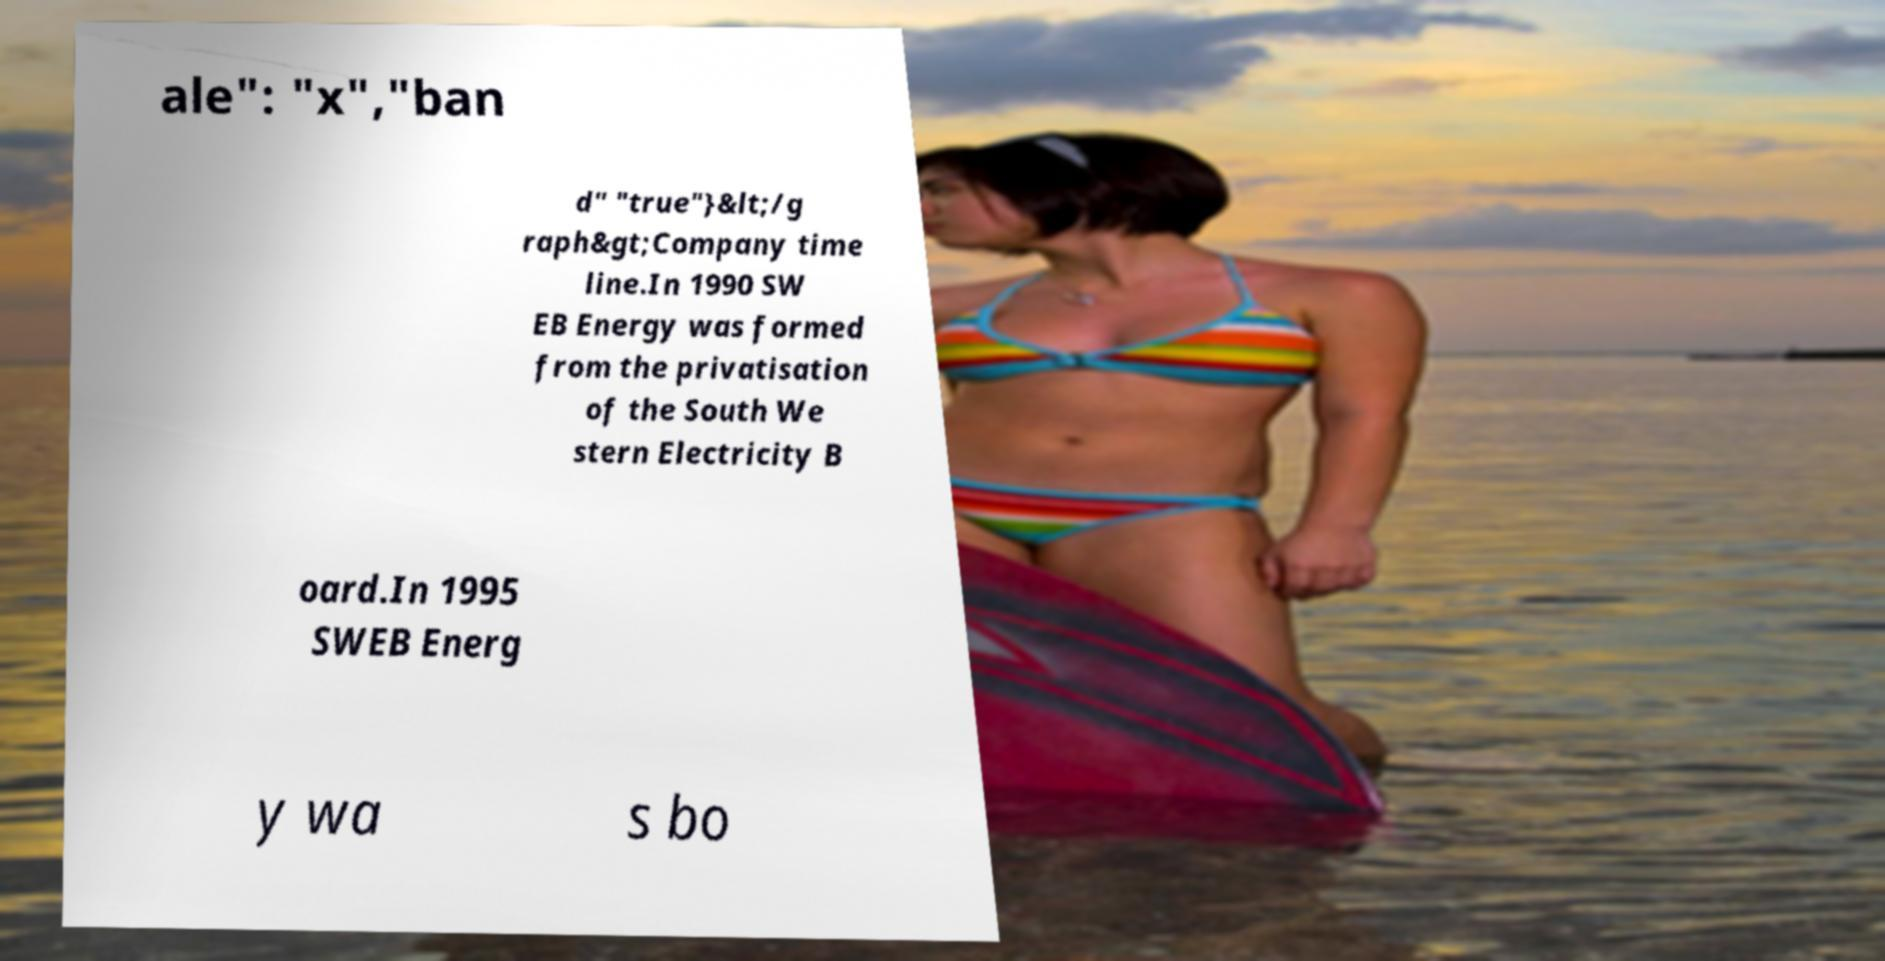I need the written content from this picture converted into text. Can you do that? ale": "x","ban d" "true"}&lt;/g raph&gt;Company time line.In 1990 SW EB Energy was formed from the privatisation of the South We stern Electricity B oard.In 1995 SWEB Energ y wa s bo 